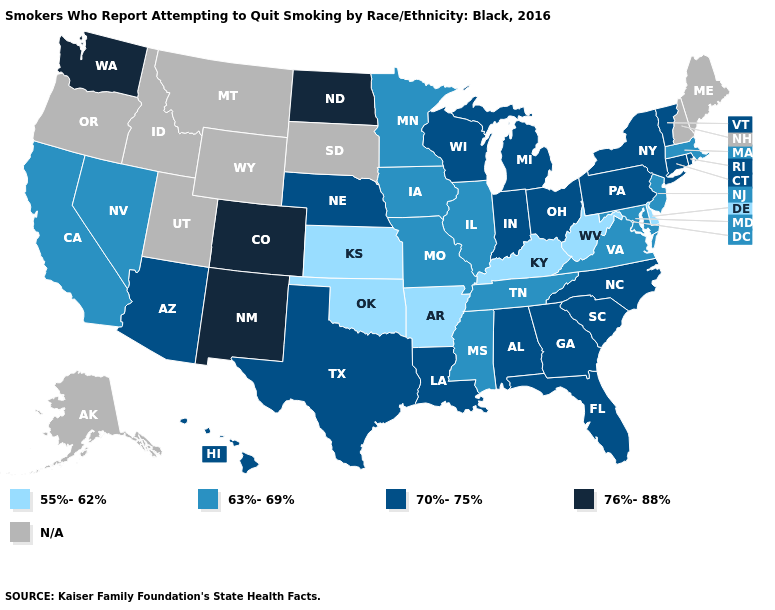Name the states that have a value in the range 63%-69%?
Short answer required. California, Illinois, Iowa, Maryland, Massachusetts, Minnesota, Mississippi, Missouri, Nevada, New Jersey, Tennessee, Virginia. Which states have the lowest value in the South?
Answer briefly. Arkansas, Delaware, Kentucky, Oklahoma, West Virginia. Which states have the highest value in the USA?
Concise answer only. Colorado, New Mexico, North Dakota, Washington. Name the states that have a value in the range N/A?
Be succinct. Alaska, Idaho, Maine, Montana, New Hampshire, Oregon, South Dakota, Utah, Wyoming. Does Delaware have the highest value in the South?
Quick response, please. No. What is the value of Wyoming?
Concise answer only. N/A. Does New Mexico have the lowest value in the West?
Quick response, please. No. Name the states that have a value in the range N/A?
Concise answer only. Alaska, Idaho, Maine, Montana, New Hampshire, Oregon, South Dakota, Utah, Wyoming. Does the map have missing data?
Concise answer only. Yes. What is the value of Georgia?
Short answer required. 70%-75%. Name the states that have a value in the range N/A?
Short answer required. Alaska, Idaho, Maine, Montana, New Hampshire, Oregon, South Dakota, Utah, Wyoming. Name the states that have a value in the range 63%-69%?
Keep it brief. California, Illinois, Iowa, Maryland, Massachusetts, Minnesota, Mississippi, Missouri, Nevada, New Jersey, Tennessee, Virginia. Among the states that border Illinois , does Iowa have the highest value?
Be succinct. No. 